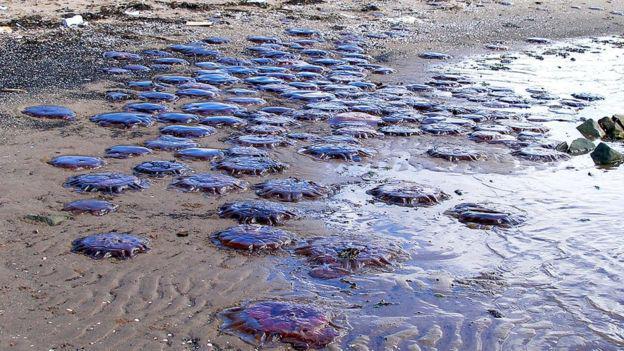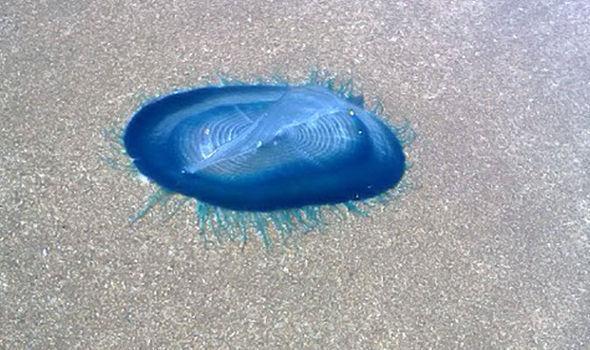The first image is the image on the left, the second image is the image on the right. Examine the images to the left and right. Is the description "Each picture only has one jellyfish." accurate? Answer yes or no. No. The first image is the image on the left, the second image is the image on the right. Considering the images on both sides, is "Each image shows one prominent beached jellyfish that resembles an inflated bluish translucent balloon." valid? Answer yes or no. No. 